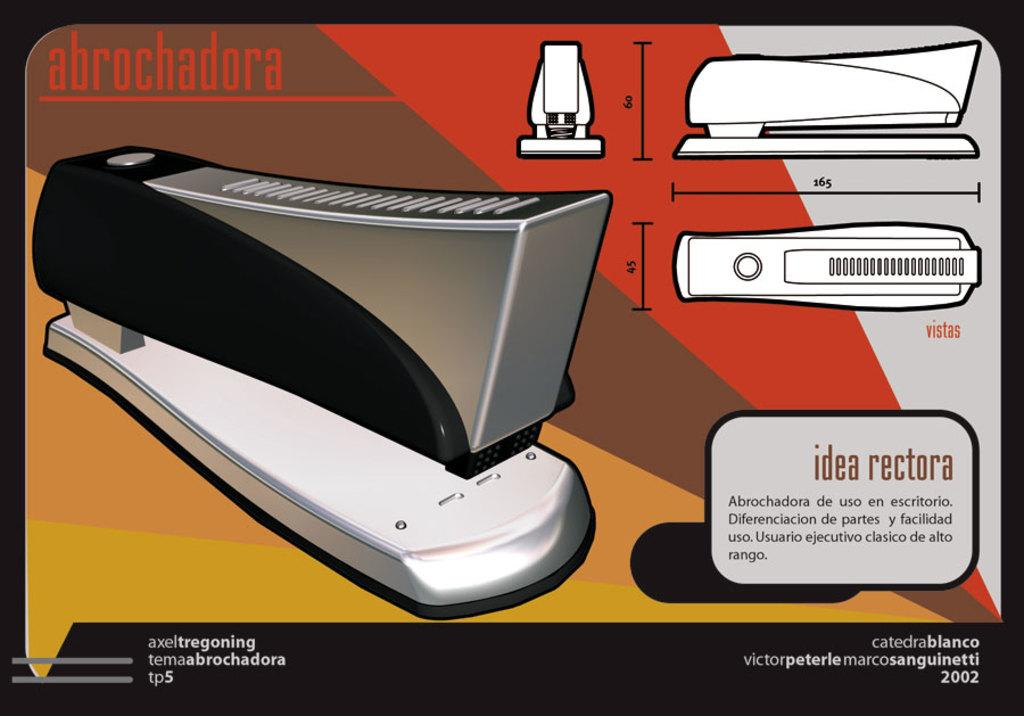<image>
Summarize the visual content of the image. a diagram of a stapler that says 'abrochadora' at the top 